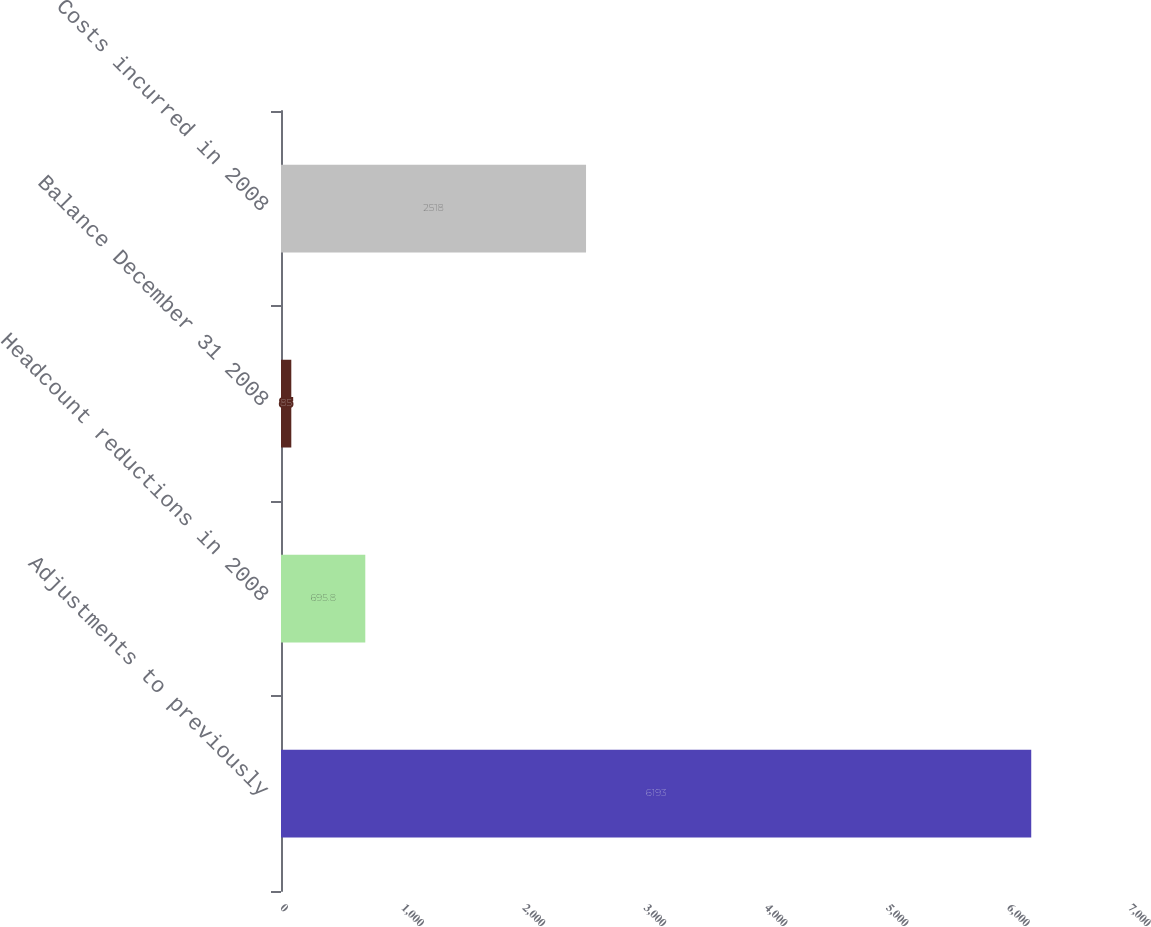<chart> <loc_0><loc_0><loc_500><loc_500><bar_chart><fcel>Adjustments to previously<fcel>Headcount reductions in 2008<fcel>Balance December 31 2008<fcel>Costs incurred in 2008<nl><fcel>6193<fcel>695.8<fcel>85<fcel>2518<nl></chart> 